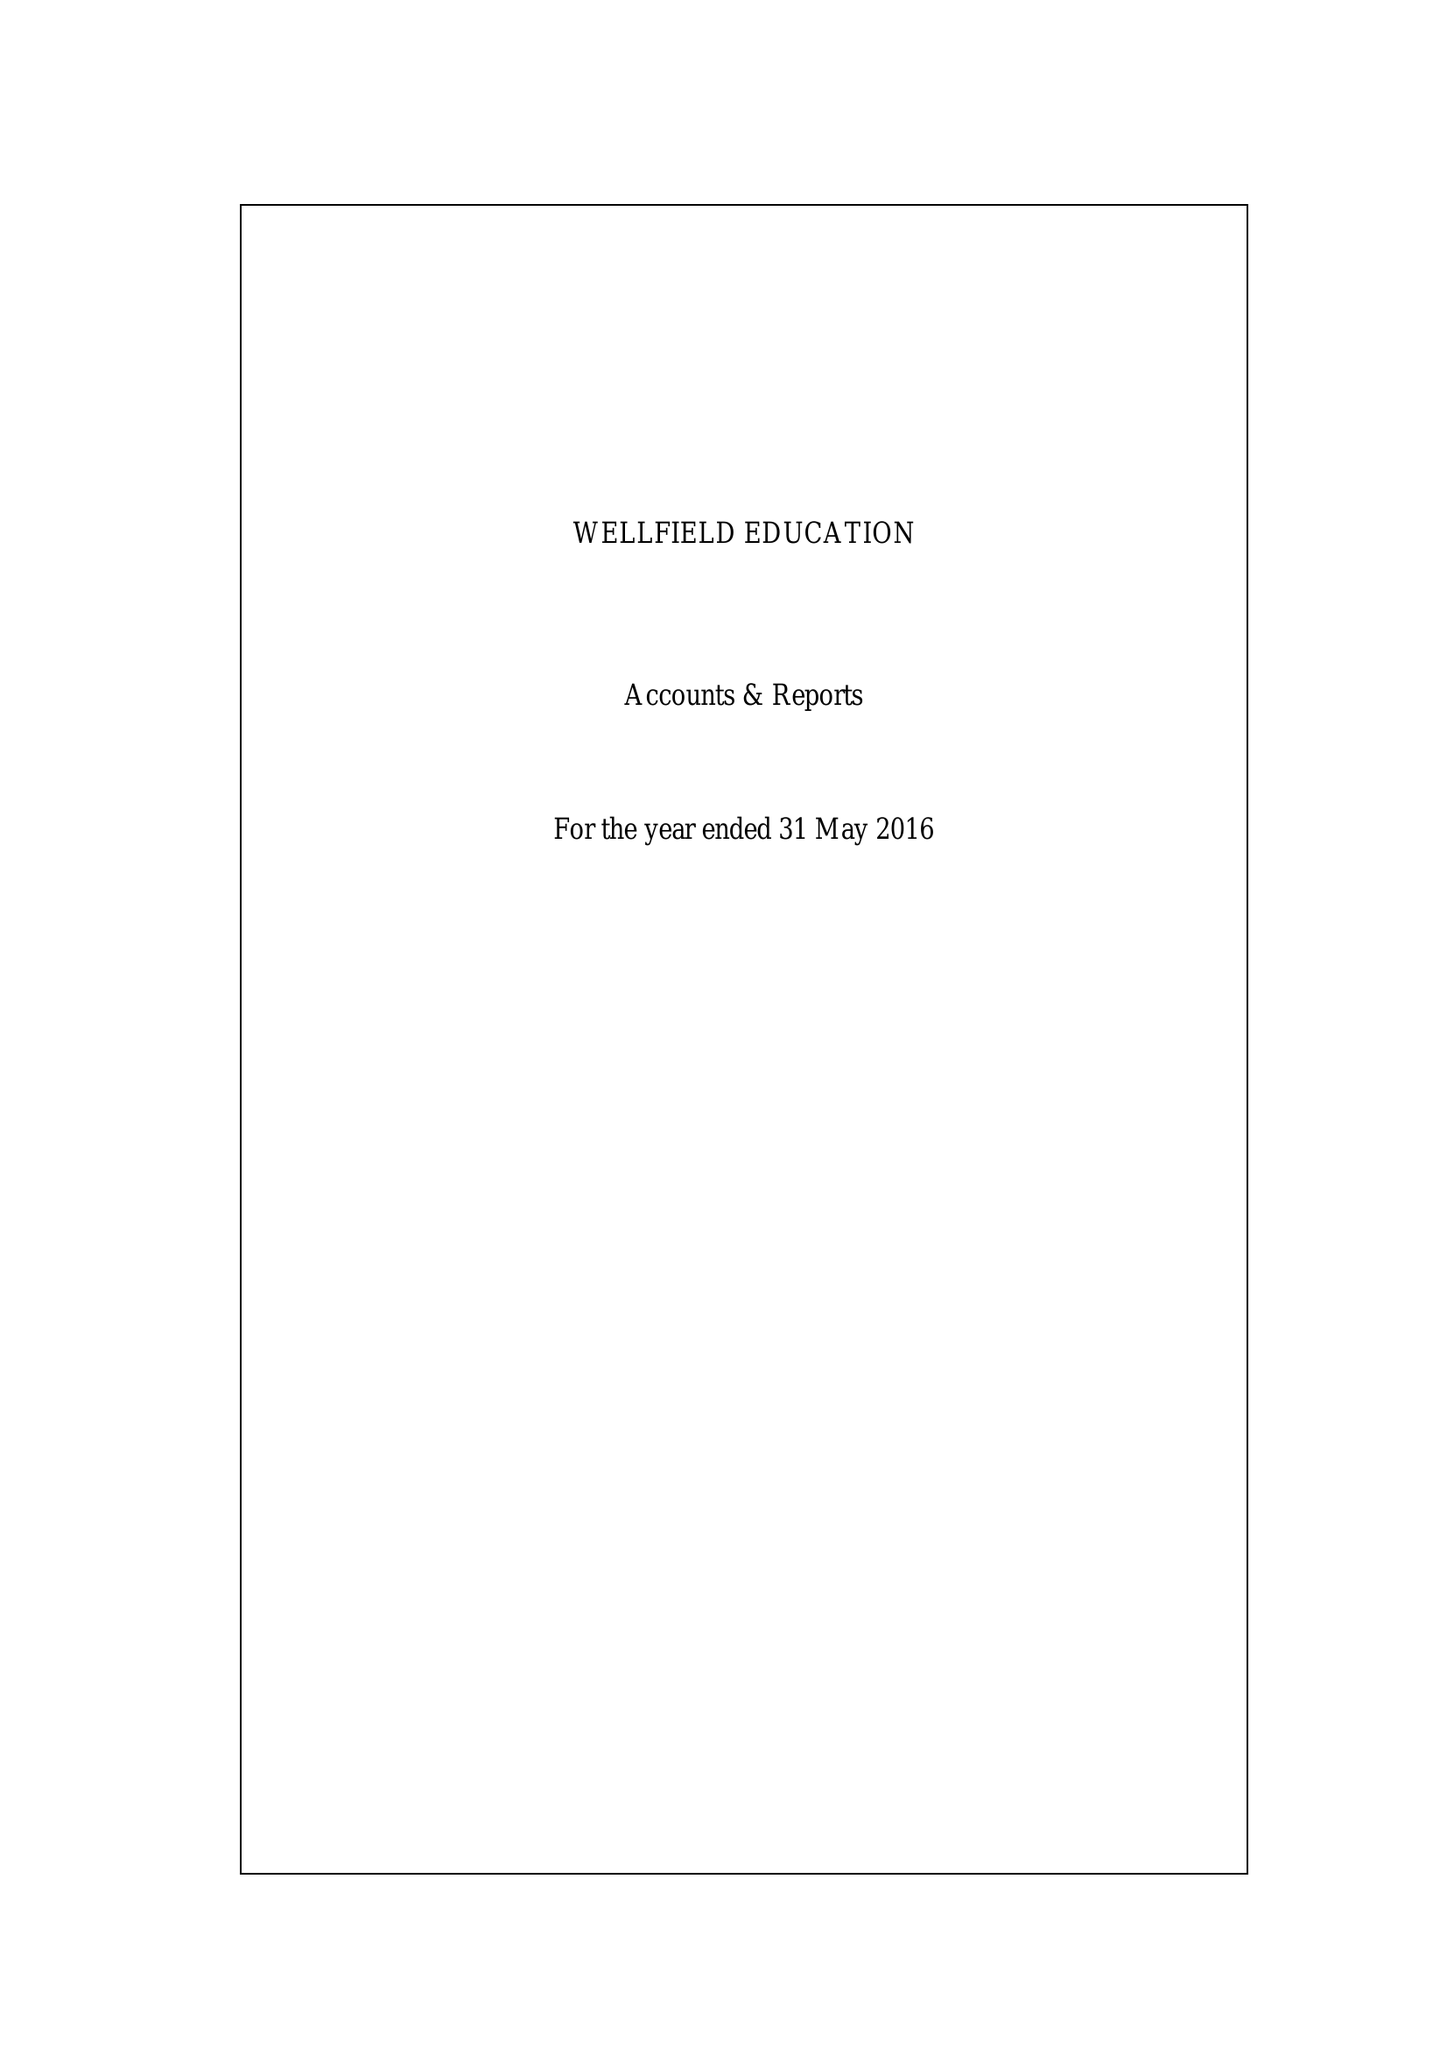What is the value for the charity_number?
Answer the question using a single word or phrase. 1139943 